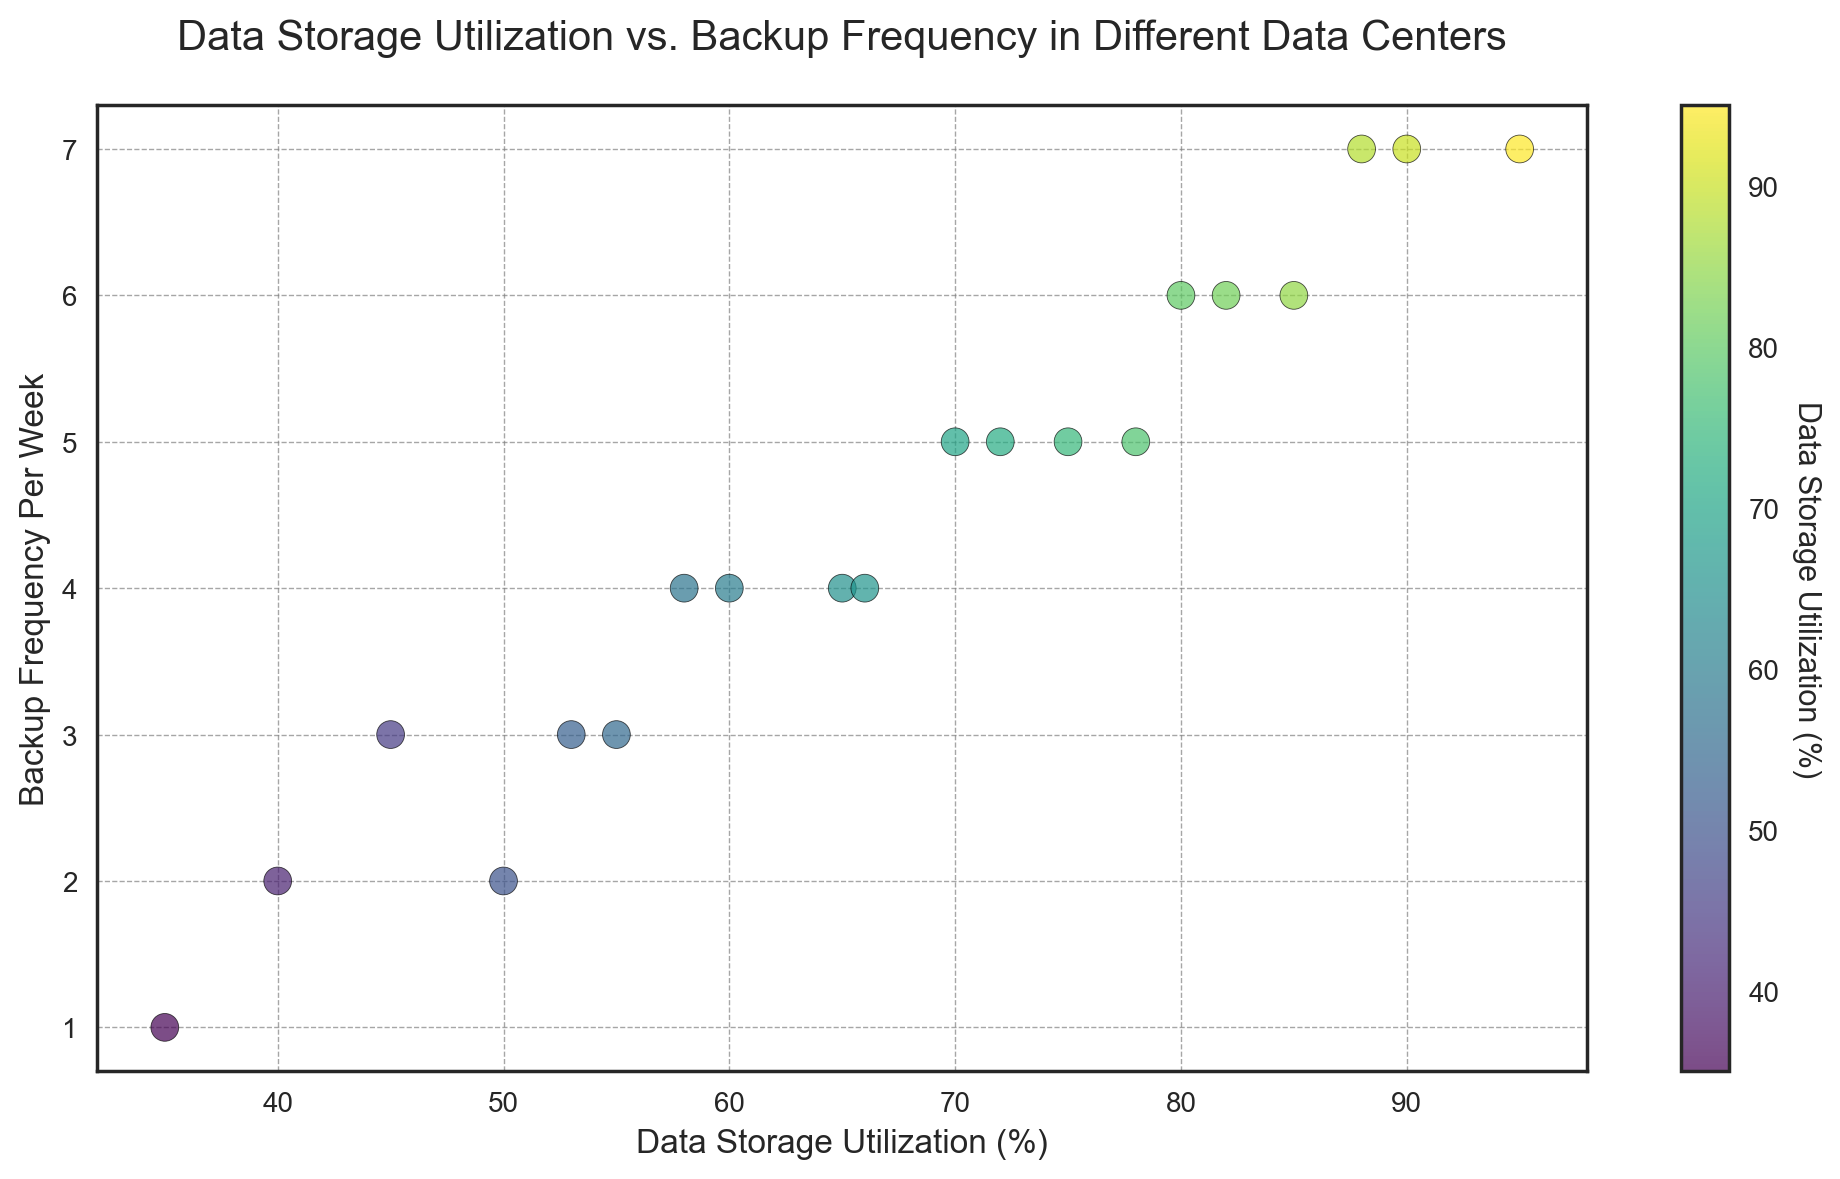Which data center has the highest backup frequency per week? The data center with the highest backup frequency per week is the one with the highest point on the y-axis. The highest backup frequency per week is 7, seen for data centers with IDs 6, 12, and 18.
Answer: Data Centers 6, 12, 18 What is the average data storage utilization for data centers with a backup frequency of 4 per week? There are four data centers with a backup frequency of 4 per week (IDs 5, 9, 15, 19). Their storage utilizations are 65%, 60%, 66%, and 58%. Sum these values: 65 + 60 + 66 + 58 = 249. Divide by 4 to find the average: 249 / 4 = 62.25%.
Answer: 62.25% Which data center has the lowest storage utilization? The data center with the lowest data storage utilization is the one with the lowest point on the x-axis. The lowest data storage utilization is 35%, corresponding to Data Center 13.
Answer: Data Center 13 Is there a correlation between higher data storage utilization and higher backup frequency per week? By observing the scatter plot, we see that the points generally trend upwards, indicating that as data storage utilization increases, the backup frequency per week also tends to increase.
Answer: Yes Which data center has the smallest circle marker in the plot? The size of the markers in the plot is directly related to the data storage utilization. Data centers with the smallest utilization will have the smallest markers. The smallest utilization is 35%, which is Data Center 13.
Answer: Data Center 13 What is the difference in data storage utilization between the data centers with the highest and lowest backup frequencies? The data center with the highest backup frequency (7) has the highest data storage utilization of 95% (Data Center 12). The lowest backup frequency (1) is linked to a data storage utilization of 35% (Data Center 13). The difference is 95% - 35% = 60%.
Answer: 60% How many data centers have a backup frequency of 5 per week and what are their storage utilizations? By looking at the plot, we identify the points aligned with 5 on the y-axis. These points correspond to Data Centers 2, 8, 14, and 20 with storage utilizations of 70%, 75%, 78%, and 72%, respectively.
Answer: 4 data centers; 70%, 75%, 78%, 72% Are there any data centers with the same data storage utilization? If yes, which ones and what is their backup frequency per week? By examining the scatter plot, we can identify the points that align vertically with the same x-axis value indicating the same storage utilization. Data storage utilizations are unique, so no centers share the same utilization values.
Answer: No Do more data centers cluster around low or high backup frequencies? By observing the distribution of points along the y-axis, more points seem to be concentrated at higher backup frequencies (5, 6, and 7) compared to lower ones (1, 2, and 3).
Answer: High backup frequencies Which data center has exactly 55% data storage utilization and what is its backup frequency? Locate the point that corresponds to 55% data storage utilization on the x-axis. This is Data Center 7, and it has a backup frequency of 3 per week.
Answer: Data Center 7, 3 